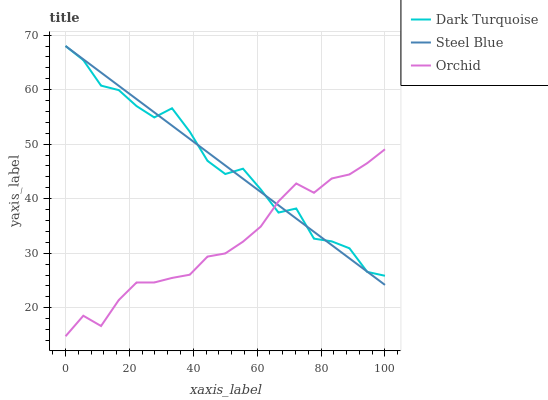Does Orchid have the minimum area under the curve?
Answer yes or no. Yes. Does Dark Turquoise have the maximum area under the curve?
Answer yes or no. Yes. Does Steel Blue have the minimum area under the curve?
Answer yes or no. No. Does Steel Blue have the maximum area under the curve?
Answer yes or no. No. Is Steel Blue the smoothest?
Answer yes or no. Yes. Is Dark Turquoise the roughest?
Answer yes or no. Yes. Is Orchid the smoothest?
Answer yes or no. No. Is Orchid the roughest?
Answer yes or no. No. Does Orchid have the lowest value?
Answer yes or no. Yes. Does Steel Blue have the lowest value?
Answer yes or no. No. Does Steel Blue have the highest value?
Answer yes or no. Yes. Does Orchid have the highest value?
Answer yes or no. No. Does Dark Turquoise intersect Steel Blue?
Answer yes or no. Yes. Is Dark Turquoise less than Steel Blue?
Answer yes or no. No. Is Dark Turquoise greater than Steel Blue?
Answer yes or no. No. 